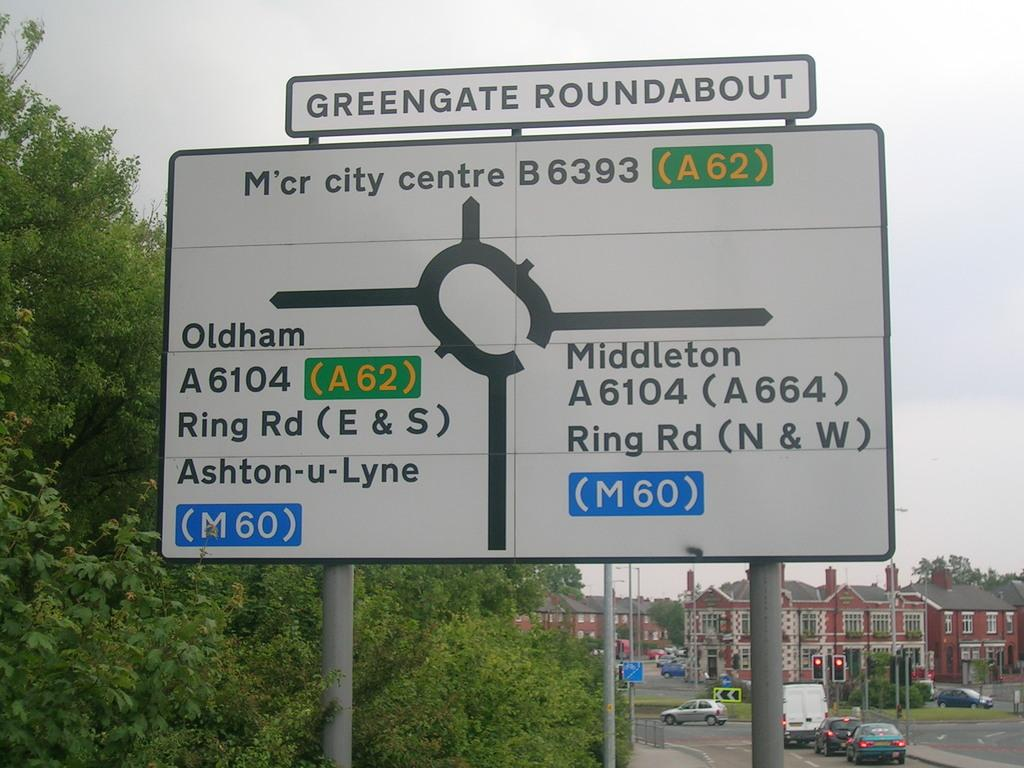<image>
Create a compact narrative representing the image presented. A white and black street sign says greengate roundabout at the top of it. 